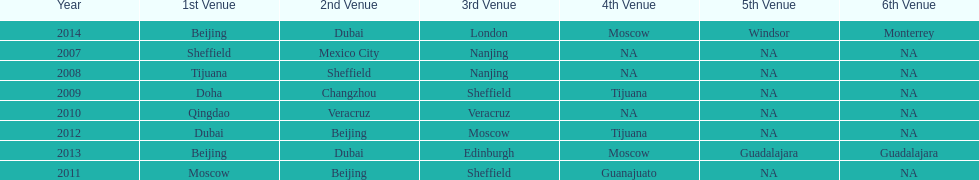In list of venues, how many years was beijing above moscow (1st venue is above 2nd venue, etc)? 3. Can you give me this table as a dict? {'header': ['Year', '1st Venue', '2nd Venue', '3rd Venue', '4th Venue', '5th Venue', '6th Venue'], 'rows': [['2014', 'Beijing', 'Dubai', 'London', 'Moscow', 'Windsor', 'Monterrey'], ['2007', 'Sheffield', 'Mexico City', 'Nanjing', 'NA', 'NA', 'NA'], ['2008', 'Tijuana', 'Sheffield', 'Nanjing', 'NA', 'NA', 'NA'], ['2009', 'Doha', 'Changzhou', 'Sheffield', 'Tijuana', 'NA', 'NA'], ['2010', 'Qingdao', 'Veracruz', 'Veracruz', 'NA', 'NA', 'NA'], ['2012', 'Dubai', 'Beijing', 'Moscow', 'Tijuana', 'NA', 'NA'], ['2013', 'Beijing', 'Dubai', 'Edinburgh', 'Moscow', 'Guadalajara', 'Guadalajara'], ['2011', 'Moscow', 'Beijing', 'Sheffield', 'Guanajuato', 'NA', 'NA']]} 